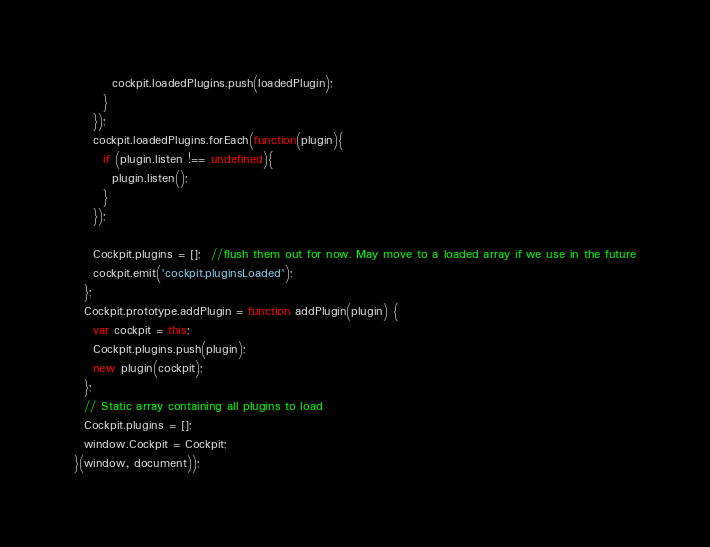<code> <loc_0><loc_0><loc_500><loc_500><_JavaScript_>        cockpit.loadedPlugins.push(loadedPlugin);
      }
    });
    cockpit.loadedPlugins.forEach(function(plugin){
      if (plugin.listen !== undefined){
        plugin.listen();
      }
    });

    Cockpit.plugins = [];  //flush them out for now. May move to a loaded array if we use in the future
    cockpit.emit('cockpit.pluginsLoaded');
  };
  Cockpit.prototype.addPlugin = function addPlugin(plugin) {
    var cockpit = this;
    Cockpit.plugins.push(plugin);
    new plugin(cockpit);
  };
  // Static array containing all plugins to load
  Cockpit.plugins = [];
  window.Cockpit = Cockpit;
}(window, document));
</code> 